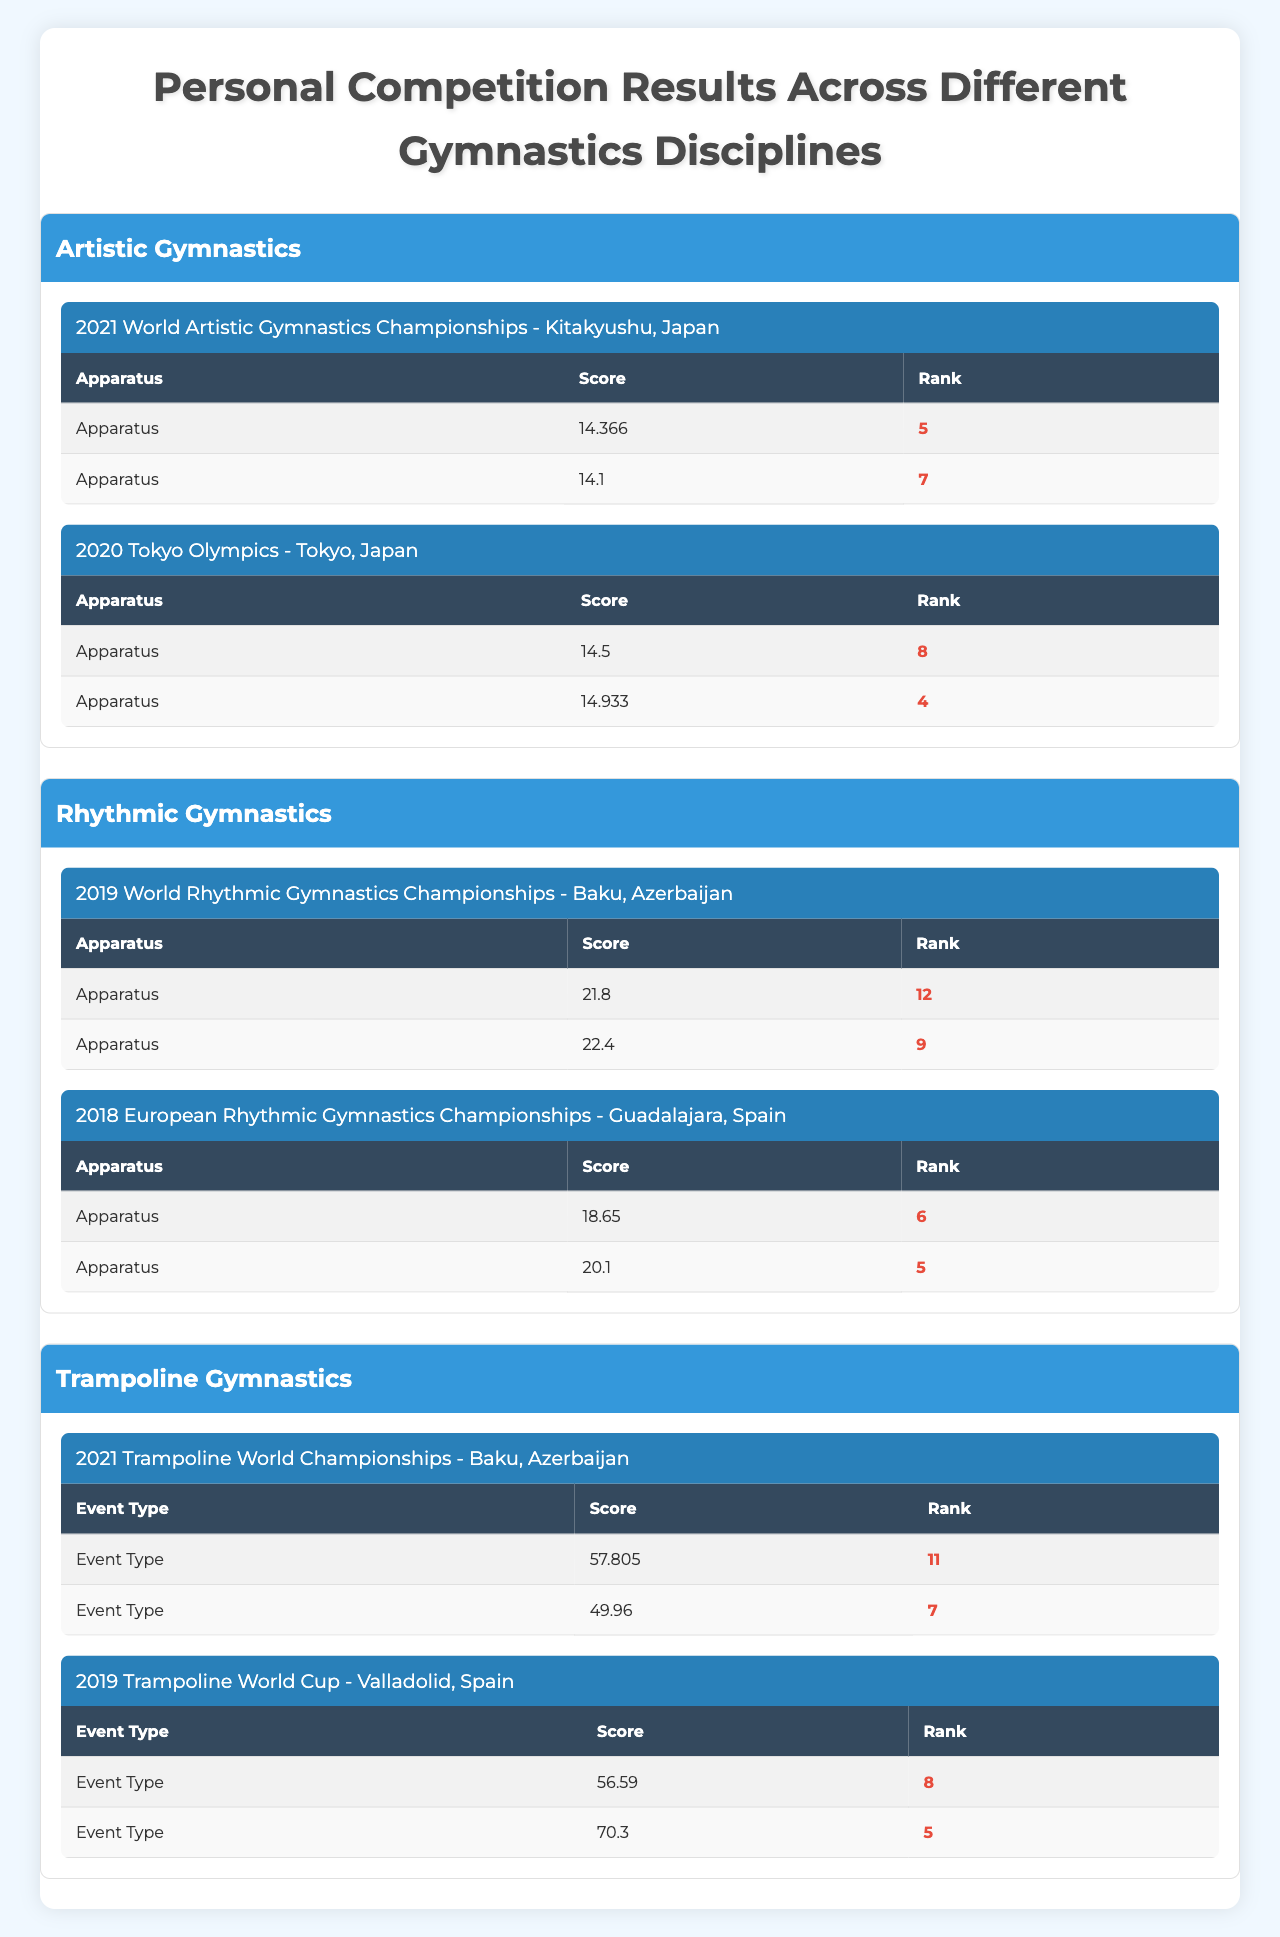What was your highest score in Artistic Gymnastics? The highest score in Artistic Gymnastics was 14.933 recorded at the 2020 Tokyo Olympics on the Vault apparatus.
Answer: 14.933 Which event did you rank the highest in Rhythmic Gymnastics? The highest rank in Rhythmic Gymnastics was 5th place achieved at the 2018 European Rhythmic Gymnastics Championships in the Clubs event.
Answer: 5th place In how many events did you compete in the 2021 World Artistic Gymnastics Championships? I competed in 2 events at the 2021 World Artistic Gymnastics Championships, which were Balance Beam and Floor Exercise.
Answer: 2 events What was the average score across all your events in Trampoline Gymnastics? The total score for Trampoline Gymnastics is (57.805 + 49.960 + 56.590 + 70.300) = 234.655, and there are 4 events, so the average score is 234.655 / 4 = 58.66375.
Answer: Approximately 58.66 Did you ever finish in the top 3 in any of the events listed? No, there were no finishes in the top 3; the highest rank was 4th place in the Vault at the 2020 Tokyo Olympics.
Answer: No Which discipline has the highest recorded score in any event? The highest recorded score is 70.300 in the Double Mini-Trampoline event at the 2019 Trampoline World Cup.
Answer: 70.300 How many events did you participate in for Rhythmic Gymnastics? I participated in 2 events for Rhythmic Gymnastics: the 2019 World Rhythmic Gymnastics Championships and the 2018 European Championships.
Answer: 2 events What is the total rank position across all events in Artistic Gymnastics? The total rank positions in Artistic Gymnastics are (5 + 7 + 8 + 4) = 24.
Answer: 24 Was your score on the Ribbon higher than your score on the Hoop in Rhythmic Gymnastics? The score on the Ribbon was 18.650, which is lower than the score on the Hoop at 21.800.
Answer: No What was your lowest rank in Trampoline Gymnastics? The lowest rank in Trampoline Gymnastics was 11th place in the Individual event at the 2021 Trampoline World Championships.
Answer: 11th place 